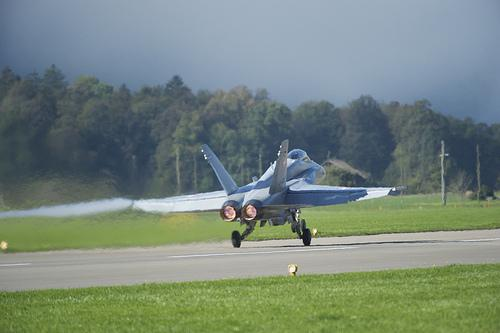Question: why is it so bright?
Choices:
A. Sunny.
B. All the lights are on.
C. Eyes haven't adjusted to the light.
D. The colors are neon.
Answer with the letter. Answer: A Question: who is driving the plane?
Choices:
A. The captain.
B. The man.
C. The pilot.
D. The woman.
Answer with the letter. Answer: C Question: what time of day is it?
Choices:
A. Noon.
B. Morning.
C. Afternoon.
D. Evening.
Answer with the letter. Answer: B Question: when was the photo taken?
Choices:
A. Morning.
B. Day time.
C. Sunset.
D. Afternoon.
Answer with the letter. Answer: B Question: what is on the ground?
Choices:
A. Grass.
B. Toys.
C. Sprinkler.
D. Spider.
Answer with the letter. Answer: A Question: where was the photo taken?
Choices:
A. On a plane runway.
B. On the Subway.
C. On the train.
D. On the bus.
Answer with the letter. Answer: A 